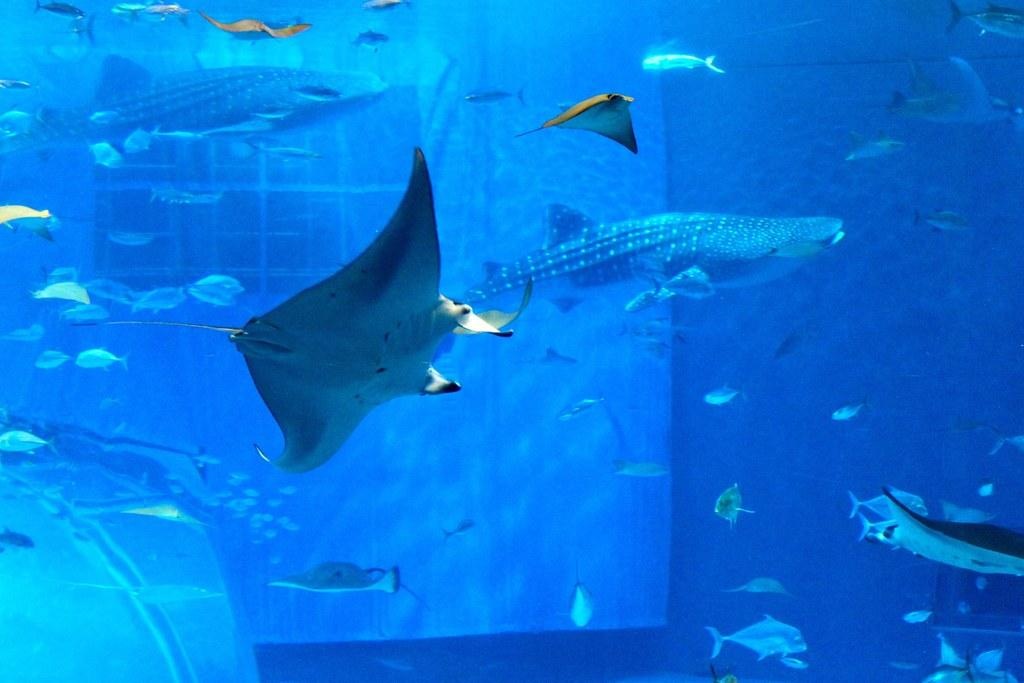What is the main object in the image? There is an aquarium in the image. What can be seen inside the aquarium? There are many fish in the water of the aquarium. What type of pencil can be seen floating in the water of the aquarium? There is no pencil present in the image; it is an aquarium with fish in the water. 